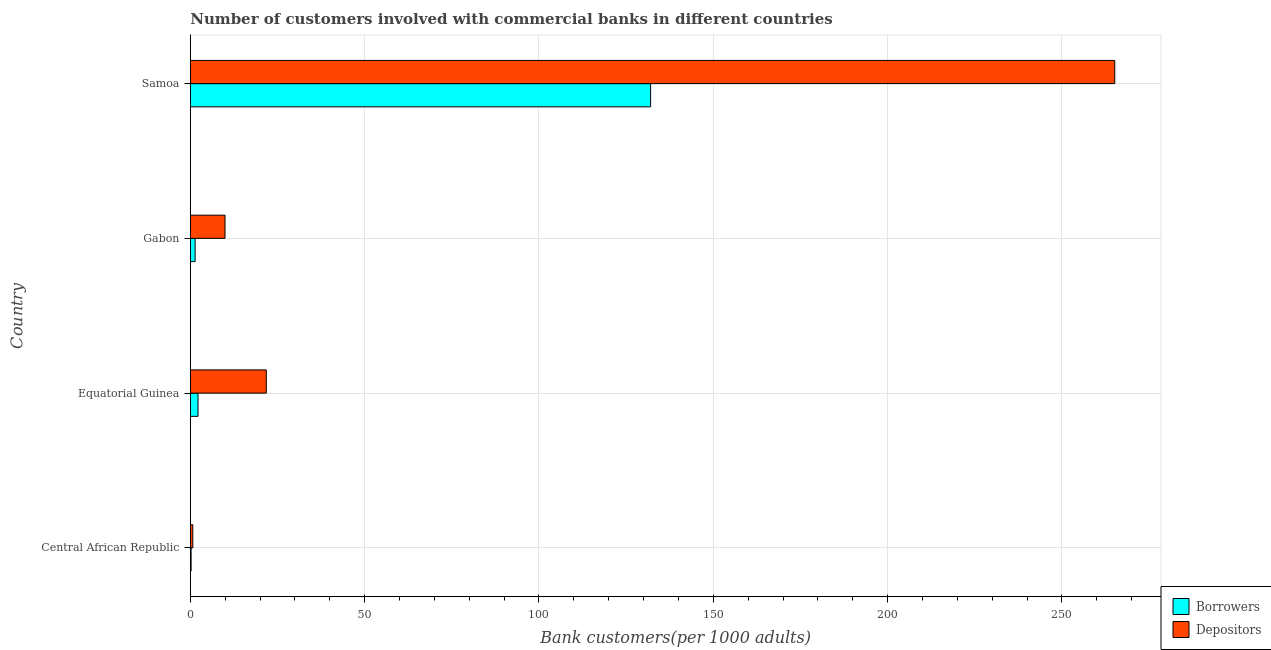Are the number of bars on each tick of the Y-axis equal?
Provide a short and direct response. Yes. How many bars are there on the 2nd tick from the top?
Provide a short and direct response. 2. How many bars are there on the 4th tick from the bottom?
Keep it short and to the point. 2. What is the label of the 1st group of bars from the top?
Keep it short and to the point. Samoa. What is the number of borrowers in Samoa?
Your answer should be very brief. 132.03. Across all countries, what is the maximum number of depositors?
Provide a short and direct response. 265.15. Across all countries, what is the minimum number of borrowers?
Keep it short and to the point. 0.23. In which country was the number of borrowers maximum?
Your response must be concise. Samoa. In which country was the number of depositors minimum?
Offer a very short reply. Central African Republic. What is the total number of borrowers in the graph?
Your answer should be compact. 135.87. What is the difference between the number of borrowers in Gabon and that in Samoa?
Your answer should be very brief. -130.64. What is the difference between the number of depositors in Samoa and the number of borrowers in Gabon?
Provide a short and direct response. 263.77. What is the average number of borrowers per country?
Provide a succinct answer. 33.97. What is the difference between the number of depositors and number of borrowers in Gabon?
Your answer should be very brief. 8.57. What is the ratio of the number of depositors in Equatorial Guinea to that in Gabon?
Offer a very short reply. 2.19. Is the number of borrowers in Gabon less than that in Samoa?
Make the answer very short. Yes. Is the difference between the number of borrowers in Central African Republic and Samoa greater than the difference between the number of depositors in Central African Republic and Samoa?
Your response must be concise. Yes. What is the difference between the highest and the second highest number of borrowers?
Provide a succinct answer. 129.81. What is the difference between the highest and the lowest number of borrowers?
Give a very brief answer. 131.79. In how many countries, is the number of depositors greater than the average number of depositors taken over all countries?
Your answer should be very brief. 1. Is the sum of the number of borrowers in Equatorial Guinea and Gabon greater than the maximum number of depositors across all countries?
Offer a very short reply. No. What does the 2nd bar from the top in Central African Republic represents?
Make the answer very short. Borrowers. What does the 1st bar from the bottom in Gabon represents?
Keep it short and to the point. Borrowers. How many bars are there?
Your answer should be very brief. 8. Are all the bars in the graph horizontal?
Make the answer very short. Yes. Are the values on the major ticks of X-axis written in scientific E-notation?
Provide a short and direct response. No. Does the graph contain any zero values?
Give a very brief answer. No. Does the graph contain grids?
Make the answer very short. Yes. How many legend labels are there?
Your answer should be compact. 2. What is the title of the graph?
Your answer should be compact. Number of customers involved with commercial banks in different countries. What is the label or title of the X-axis?
Ensure brevity in your answer.  Bank customers(per 1000 adults). What is the Bank customers(per 1000 adults) of Borrowers in Central African Republic?
Your answer should be compact. 0.23. What is the Bank customers(per 1000 adults) of Depositors in Central African Republic?
Your answer should be compact. 0.72. What is the Bank customers(per 1000 adults) of Borrowers in Equatorial Guinea?
Offer a terse response. 2.22. What is the Bank customers(per 1000 adults) in Depositors in Equatorial Guinea?
Offer a very short reply. 21.8. What is the Bank customers(per 1000 adults) in Borrowers in Gabon?
Give a very brief answer. 1.38. What is the Bank customers(per 1000 adults) in Depositors in Gabon?
Give a very brief answer. 9.96. What is the Bank customers(per 1000 adults) in Borrowers in Samoa?
Offer a terse response. 132.03. What is the Bank customers(per 1000 adults) in Depositors in Samoa?
Give a very brief answer. 265.15. Across all countries, what is the maximum Bank customers(per 1000 adults) of Borrowers?
Your answer should be very brief. 132.03. Across all countries, what is the maximum Bank customers(per 1000 adults) in Depositors?
Offer a very short reply. 265.15. Across all countries, what is the minimum Bank customers(per 1000 adults) in Borrowers?
Give a very brief answer. 0.23. Across all countries, what is the minimum Bank customers(per 1000 adults) in Depositors?
Keep it short and to the point. 0.72. What is the total Bank customers(per 1000 adults) of Borrowers in the graph?
Give a very brief answer. 135.87. What is the total Bank customers(per 1000 adults) in Depositors in the graph?
Your answer should be very brief. 297.63. What is the difference between the Bank customers(per 1000 adults) of Borrowers in Central African Republic and that in Equatorial Guinea?
Keep it short and to the point. -1.99. What is the difference between the Bank customers(per 1000 adults) of Depositors in Central African Republic and that in Equatorial Guinea?
Your answer should be very brief. -21.09. What is the difference between the Bank customers(per 1000 adults) of Borrowers in Central African Republic and that in Gabon?
Ensure brevity in your answer.  -1.15. What is the difference between the Bank customers(per 1000 adults) of Depositors in Central African Republic and that in Gabon?
Your response must be concise. -9.24. What is the difference between the Bank customers(per 1000 adults) of Borrowers in Central African Republic and that in Samoa?
Offer a very short reply. -131.79. What is the difference between the Bank customers(per 1000 adults) in Depositors in Central African Republic and that in Samoa?
Provide a short and direct response. -264.43. What is the difference between the Bank customers(per 1000 adults) in Borrowers in Equatorial Guinea and that in Gabon?
Ensure brevity in your answer.  0.84. What is the difference between the Bank customers(per 1000 adults) in Depositors in Equatorial Guinea and that in Gabon?
Make the answer very short. 11.84. What is the difference between the Bank customers(per 1000 adults) in Borrowers in Equatorial Guinea and that in Samoa?
Offer a very short reply. -129.81. What is the difference between the Bank customers(per 1000 adults) in Depositors in Equatorial Guinea and that in Samoa?
Make the answer very short. -243.35. What is the difference between the Bank customers(per 1000 adults) in Borrowers in Gabon and that in Samoa?
Offer a very short reply. -130.64. What is the difference between the Bank customers(per 1000 adults) of Depositors in Gabon and that in Samoa?
Offer a very short reply. -255.19. What is the difference between the Bank customers(per 1000 adults) in Borrowers in Central African Republic and the Bank customers(per 1000 adults) in Depositors in Equatorial Guinea?
Your answer should be very brief. -21.57. What is the difference between the Bank customers(per 1000 adults) of Borrowers in Central African Republic and the Bank customers(per 1000 adults) of Depositors in Gabon?
Your answer should be very brief. -9.72. What is the difference between the Bank customers(per 1000 adults) in Borrowers in Central African Republic and the Bank customers(per 1000 adults) in Depositors in Samoa?
Ensure brevity in your answer.  -264.92. What is the difference between the Bank customers(per 1000 adults) in Borrowers in Equatorial Guinea and the Bank customers(per 1000 adults) in Depositors in Gabon?
Your answer should be very brief. -7.74. What is the difference between the Bank customers(per 1000 adults) of Borrowers in Equatorial Guinea and the Bank customers(per 1000 adults) of Depositors in Samoa?
Provide a short and direct response. -262.93. What is the difference between the Bank customers(per 1000 adults) of Borrowers in Gabon and the Bank customers(per 1000 adults) of Depositors in Samoa?
Give a very brief answer. -263.77. What is the average Bank customers(per 1000 adults) in Borrowers per country?
Provide a short and direct response. 33.97. What is the average Bank customers(per 1000 adults) in Depositors per country?
Your answer should be compact. 74.41. What is the difference between the Bank customers(per 1000 adults) in Borrowers and Bank customers(per 1000 adults) in Depositors in Central African Republic?
Ensure brevity in your answer.  -0.48. What is the difference between the Bank customers(per 1000 adults) of Borrowers and Bank customers(per 1000 adults) of Depositors in Equatorial Guinea?
Your answer should be compact. -19.58. What is the difference between the Bank customers(per 1000 adults) of Borrowers and Bank customers(per 1000 adults) of Depositors in Gabon?
Make the answer very short. -8.57. What is the difference between the Bank customers(per 1000 adults) of Borrowers and Bank customers(per 1000 adults) of Depositors in Samoa?
Make the answer very short. -133.12. What is the ratio of the Bank customers(per 1000 adults) in Borrowers in Central African Republic to that in Equatorial Guinea?
Provide a succinct answer. 0.11. What is the ratio of the Bank customers(per 1000 adults) of Depositors in Central African Republic to that in Equatorial Guinea?
Your answer should be very brief. 0.03. What is the ratio of the Bank customers(per 1000 adults) of Borrowers in Central African Republic to that in Gabon?
Keep it short and to the point. 0.17. What is the ratio of the Bank customers(per 1000 adults) in Depositors in Central African Republic to that in Gabon?
Provide a succinct answer. 0.07. What is the ratio of the Bank customers(per 1000 adults) in Borrowers in Central African Republic to that in Samoa?
Make the answer very short. 0. What is the ratio of the Bank customers(per 1000 adults) in Depositors in Central African Republic to that in Samoa?
Make the answer very short. 0. What is the ratio of the Bank customers(per 1000 adults) of Borrowers in Equatorial Guinea to that in Gabon?
Provide a short and direct response. 1.6. What is the ratio of the Bank customers(per 1000 adults) in Depositors in Equatorial Guinea to that in Gabon?
Your answer should be very brief. 2.19. What is the ratio of the Bank customers(per 1000 adults) of Borrowers in Equatorial Guinea to that in Samoa?
Your answer should be very brief. 0.02. What is the ratio of the Bank customers(per 1000 adults) in Depositors in Equatorial Guinea to that in Samoa?
Ensure brevity in your answer.  0.08. What is the ratio of the Bank customers(per 1000 adults) in Borrowers in Gabon to that in Samoa?
Keep it short and to the point. 0.01. What is the ratio of the Bank customers(per 1000 adults) of Depositors in Gabon to that in Samoa?
Provide a succinct answer. 0.04. What is the difference between the highest and the second highest Bank customers(per 1000 adults) in Borrowers?
Make the answer very short. 129.81. What is the difference between the highest and the second highest Bank customers(per 1000 adults) in Depositors?
Keep it short and to the point. 243.35. What is the difference between the highest and the lowest Bank customers(per 1000 adults) in Borrowers?
Provide a short and direct response. 131.79. What is the difference between the highest and the lowest Bank customers(per 1000 adults) in Depositors?
Offer a very short reply. 264.43. 